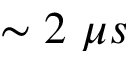Convert formula to latex. <formula><loc_0><loc_0><loc_500><loc_500>\sim 2 \ \mu s</formula> 